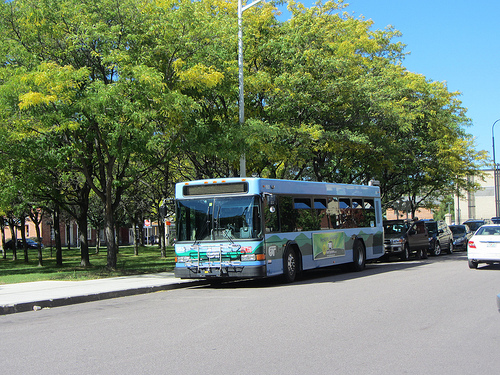Are there buses or cars? Yes, there are both buses and cars in the image. 